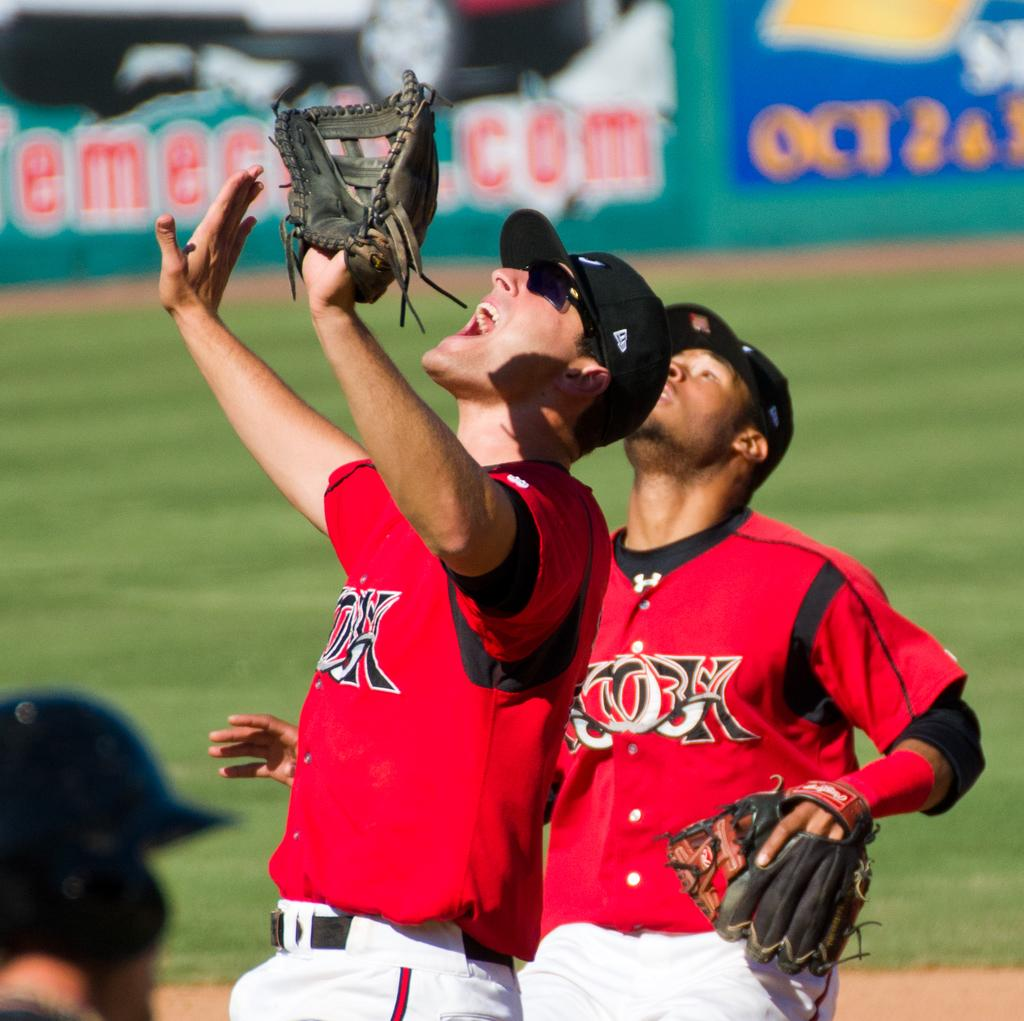Provide a one-sentence caption for the provided image. Two baseball players on the same team are looking up trying to catch a ball while in the background there is an announcement for Oct 2 & 3. 